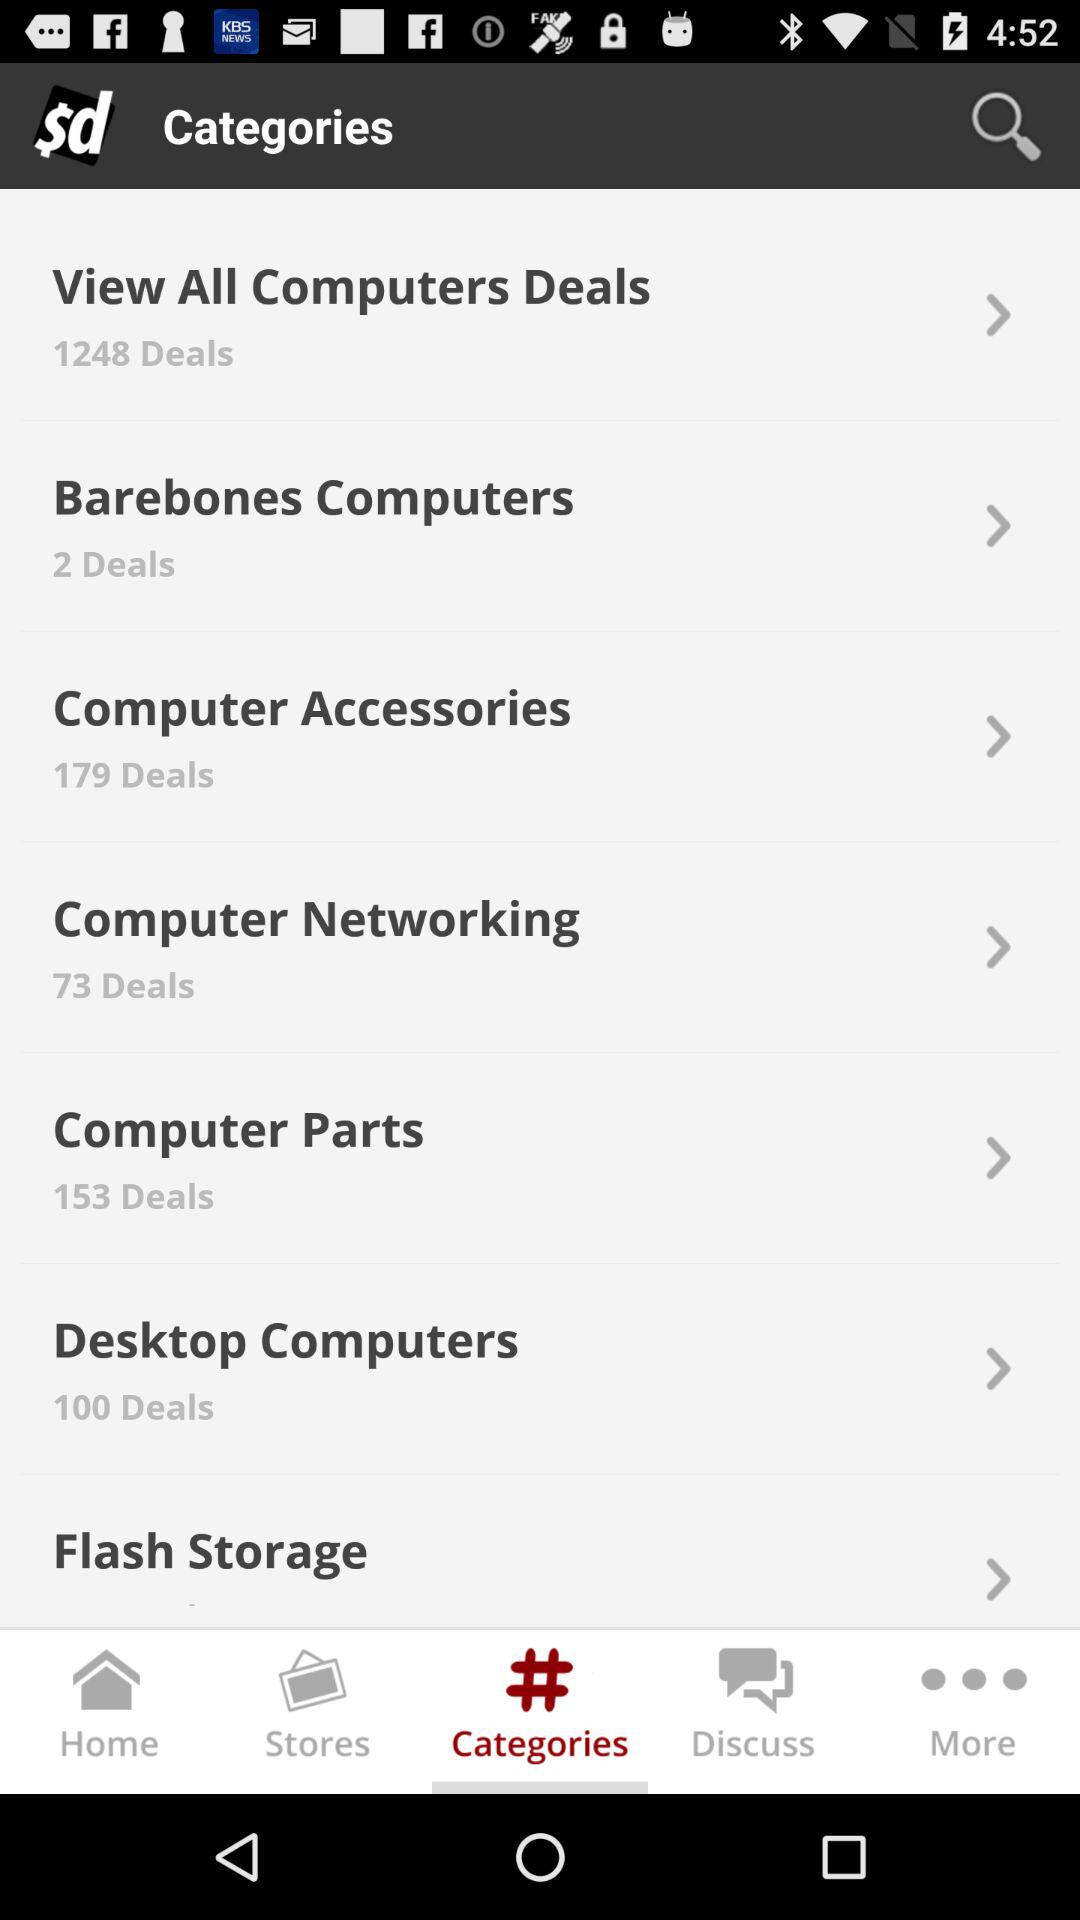How many deals are there in "Desktop Computers"? There are 100 deals. 